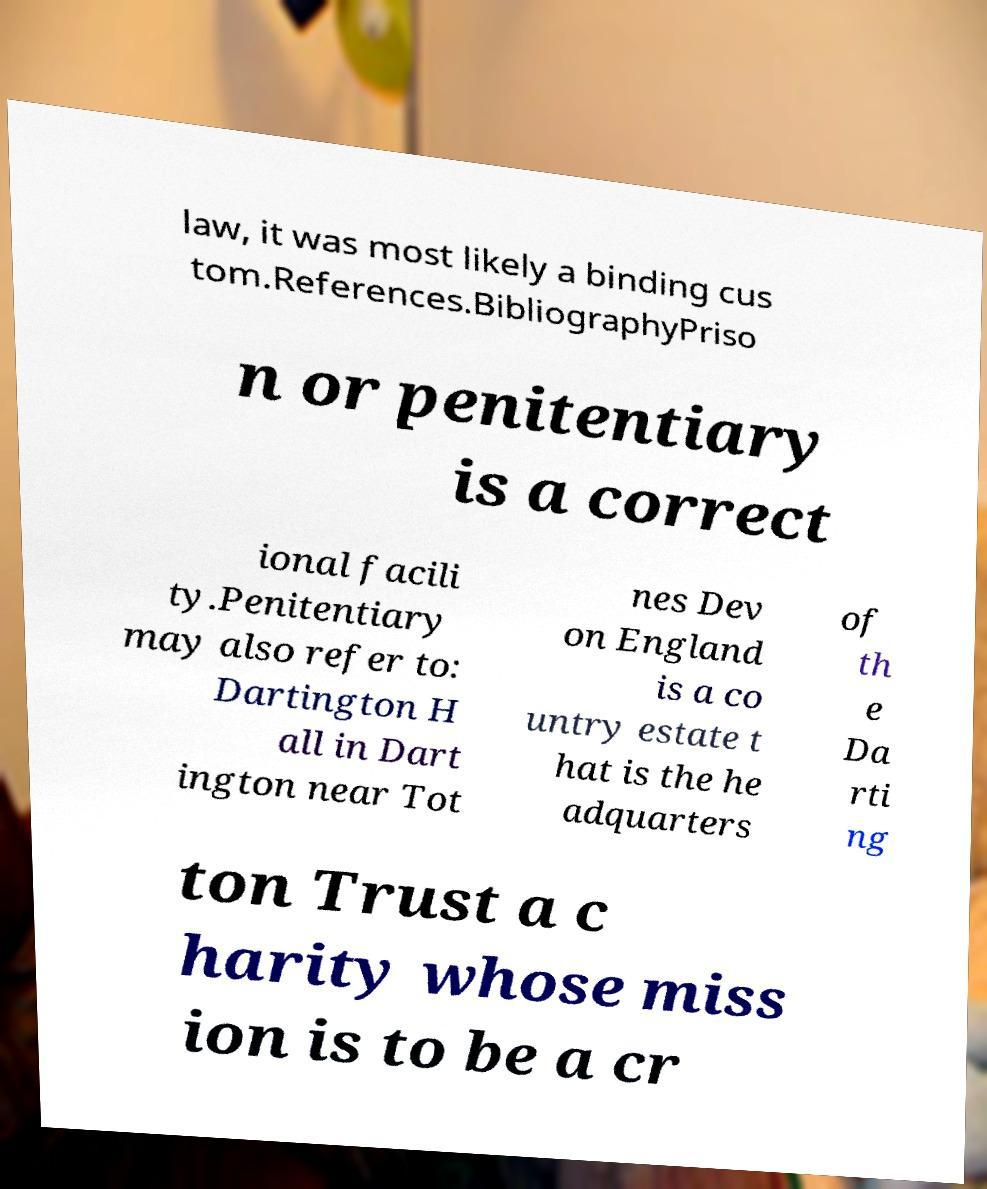Could you extract and type out the text from this image? law, it was most likely a binding cus tom.References.BibliographyPriso n or penitentiary is a correct ional facili ty.Penitentiary may also refer to: Dartington H all in Dart ington near Tot nes Dev on England is a co untry estate t hat is the he adquarters of th e Da rti ng ton Trust a c harity whose miss ion is to be a cr 